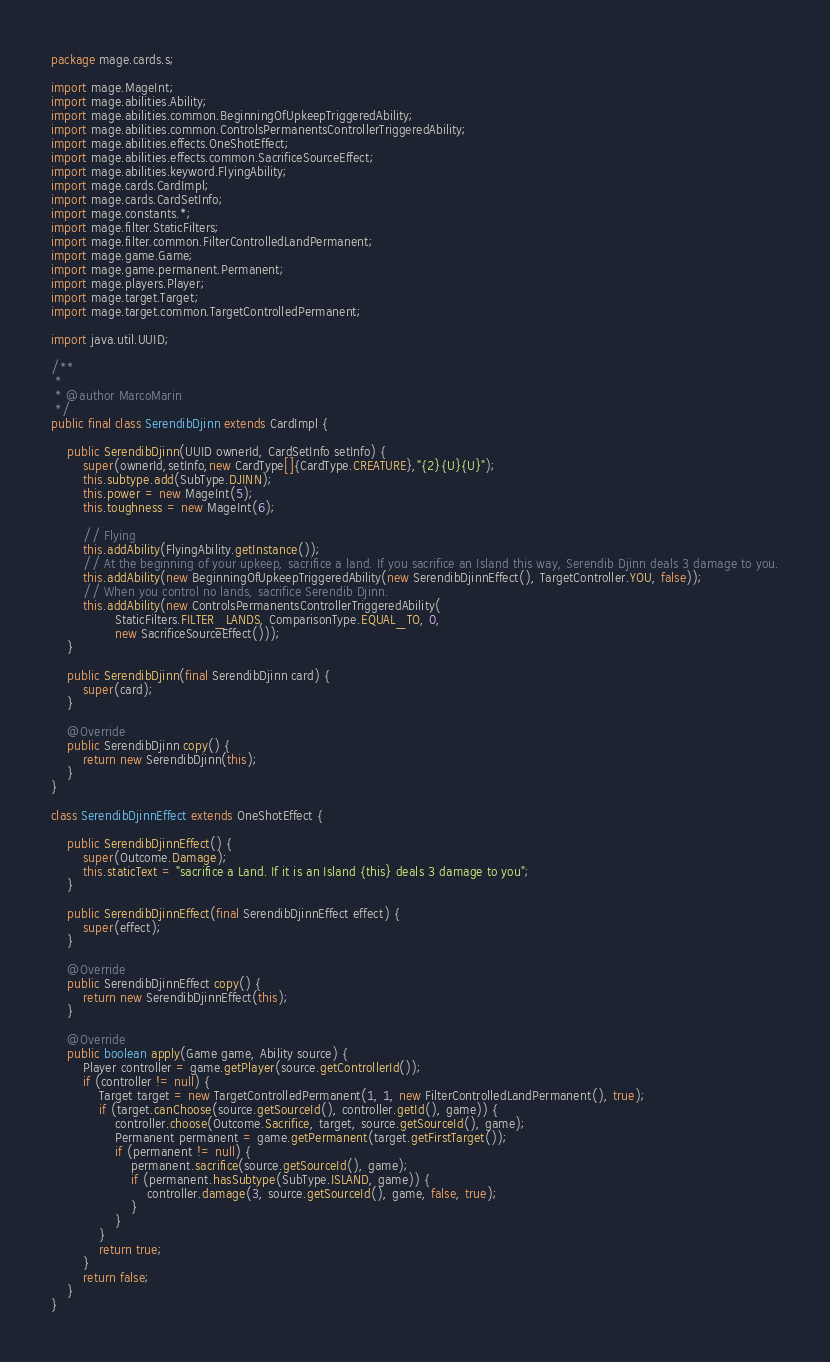Convert code to text. <code><loc_0><loc_0><loc_500><loc_500><_Java_>
package mage.cards.s;

import mage.MageInt;
import mage.abilities.Ability;
import mage.abilities.common.BeginningOfUpkeepTriggeredAbility;
import mage.abilities.common.ControlsPermanentsControllerTriggeredAbility;
import mage.abilities.effects.OneShotEffect;
import mage.abilities.effects.common.SacrificeSourceEffect;
import mage.abilities.keyword.FlyingAbility;
import mage.cards.CardImpl;
import mage.cards.CardSetInfo;
import mage.constants.*;
import mage.filter.StaticFilters;
import mage.filter.common.FilterControlledLandPermanent;
import mage.game.Game;
import mage.game.permanent.Permanent;
import mage.players.Player;
import mage.target.Target;
import mage.target.common.TargetControlledPermanent;

import java.util.UUID;

/**
 *
 * @author MarcoMarin
 */
public final class SerendibDjinn extends CardImpl {

    public SerendibDjinn(UUID ownerId, CardSetInfo setInfo) {
        super(ownerId,setInfo,new CardType[]{CardType.CREATURE},"{2}{U}{U}");
        this.subtype.add(SubType.DJINN);
        this.power = new MageInt(5);
        this.toughness = new MageInt(6);

        // Flying
        this.addAbility(FlyingAbility.getInstance());
        // At the beginning of your upkeep, sacrifice a land. If you sacrifice an Island this way, Serendib Djinn deals 3 damage to you.
        this.addAbility(new BeginningOfUpkeepTriggeredAbility(new SerendibDjinnEffect(), TargetController.YOU, false));
        // When you control no lands, sacrifice Serendib Djinn.
        this.addAbility(new ControlsPermanentsControllerTriggeredAbility(
                StaticFilters.FILTER_LANDS, ComparisonType.EQUAL_TO, 0,
                new SacrificeSourceEffect()));
    }

    public SerendibDjinn(final SerendibDjinn card) {
        super(card);
    }

    @Override
    public SerendibDjinn copy() {
        return new SerendibDjinn(this);
    }
}

class SerendibDjinnEffect extends OneShotEffect {

    public SerendibDjinnEffect() {
        super(Outcome.Damage);
        this.staticText = "sacrifice a Land. If it is an Island {this} deals 3 damage to you";
    }

    public SerendibDjinnEffect(final SerendibDjinnEffect effect) {
        super(effect);
    }

    @Override
    public SerendibDjinnEffect copy() {
        return new SerendibDjinnEffect(this);
    }

    @Override
    public boolean apply(Game game, Ability source) {
        Player controller = game.getPlayer(source.getControllerId());
        if (controller != null) {
            Target target = new TargetControlledPermanent(1, 1, new FilterControlledLandPermanent(), true);
            if (target.canChoose(source.getSourceId(), controller.getId(), game)) {
                controller.choose(Outcome.Sacrifice, target, source.getSourceId(), game);
                Permanent permanent = game.getPermanent(target.getFirstTarget());
                if (permanent != null) {
                    permanent.sacrifice(source.getSourceId(), game);
                    if (permanent.hasSubtype(SubType.ISLAND, game)) {
                        controller.damage(3, source.getSourceId(), game, false, true);
                    }
                }
            }
            return true;
        }
        return false;
    }
}
</code> 